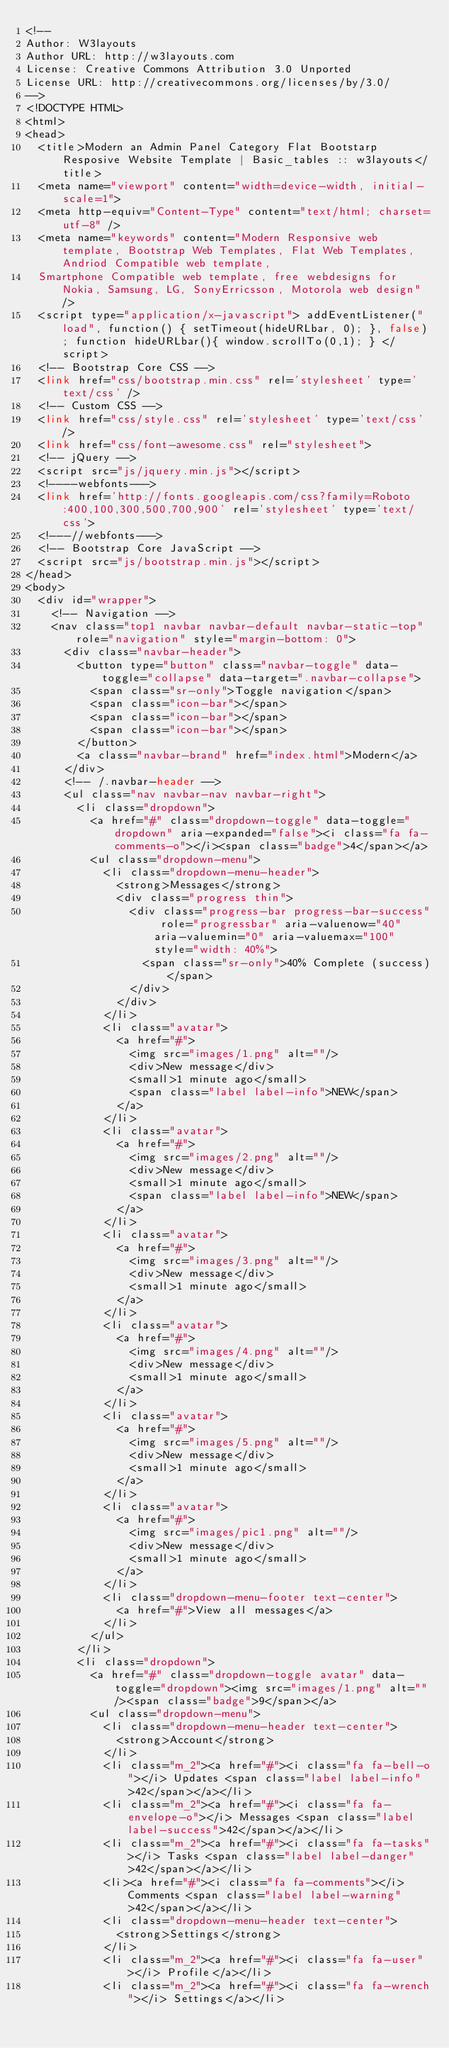<code> <loc_0><loc_0><loc_500><loc_500><_PHP_><!--
Author: W3layouts
Author URL: http://w3layouts.com
License: Creative Commons Attribution 3.0 Unported
License URL: http://creativecommons.org/licenses/by/3.0/
-->
<!DOCTYPE HTML>
<html>
<head>
	<title>Modern an Admin Panel Category Flat Bootstarp Resposive Website Template | Basic_tables :: w3layouts</title>
	<meta name="viewport" content="width=device-width, initial-scale=1">
	<meta http-equiv="Content-Type" content="text/html; charset=utf-8" />
	<meta name="keywords" content="Modern Responsive web template, Bootstrap Web Templates, Flat Web Templates, Andriod Compatible web template,
	Smartphone Compatible web template, free webdesigns for Nokia, Samsung, LG, SonyErricsson, Motorola web design" />
	<script type="application/x-javascript"> addEventListener("load", function() { setTimeout(hideURLbar, 0); }, false); function hideURLbar(){ window.scrollTo(0,1); } </script>
	<!-- Bootstrap Core CSS -->
	<link href="css/bootstrap.min.css" rel='stylesheet' type='text/css' />
	<!-- Custom CSS -->
	<link href="css/style.css" rel='stylesheet' type='text/css' />
	<link href="css/font-awesome.css" rel="stylesheet">
	<!-- jQuery -->
	<script src="js/jquery.min.js"></script>
	<!----webfonts--->
	<link href='http://fonts.googleapis.com/css?family=Roboto:400,100,300,500,700,900' rel='stylesheet' type='text/css'>
	<!---//webfonts--->
	<!-- Bootstrap Core JavaScript -->
	<script src="js/bootstrap.min.js"></script>
</head>
<body>
	<div id="wrapper">
		<!-- Navigation -->
		<nav class="top1 navbar navbar-default navbar-static-top" role="navigation" style="margin-bottom: 0">
			<div class="navbar-header">
				<button type="button" class="navbar-toggle" data-toggle="collapse" data-target=".navbar-collapse">
					<span class="sr-only">Toggle navigation</span>
					<span class="icon-bar"></span>
					<span class="icon-bar"></span>
					<span class="icon-bar"></span>
				</button>
				<a class="navbar-brand" href="index.html">Modern</a>
			</div>
			<!-- /.navbar-header -->
			<ul class="nav navbar-nav navbar-right">
				<li class="dropdown">
					<a href="#" class="dropdown-toggle" data-toggle="dropdown" aria-expanded="false"><i class="fa fa-comments-o"></i><span class="badge">4</span></a>
					<ul class="dropdown-menu">
						<li class="dropdown-menu-header">
							<strong>Messages</strong>
							<div class="progress thin">
								<div class="progress-bar progress-bar-success" role="progressbar" aria-valuenow="40" aria-valuemin="0" aria-valuemax="100" style="width: 40%">
									<span class="sr-only">40% Complete (success)</span>
								</div>
							</div>
						</li>
						<li class="avatar">
							<a href="#">
								<img src="images/1.png" alt=""/>
								<div>New message</div>
								<small>1 minute ago</small>
								<span class="label label-info">NEW</span>
							</a>
						</li>
						<li class="avatar">
							<a href="#">
								<img src="images/2.png" alt=""/>
								<div>New message</div>
								<small>1 minute ago</small>
								<span class="label label-info">NEW</span>
							</a>
						</li>
						<li class="avatar">
							<a href="#">
								<img src="images/3.png" alt=""/>
								<div>New message</div>
								<small>1 minute ago</small>
							</a>
						</li>
						<li class="avatar">
							<a href="#">
								<img src="images/4.png" alt=""/>
								<div>New message</div>
								<small>1 minute ago</small>
							</a>
						</li>
						<li class="avatar">
							<a href="#">
								<img src="images/5.png" alt=""/>
								<div>New message</div>
								<small>1 minute ago</small>
							</a>
						</li>
						<li class="avatar">
							<a href="#">
								<img src="images/pic1.png" alt=""/>
								<div>New message</div>
								<small>1 minute ago</small>
							</a>
						</li>
						<li class="dropdown-menu-footer text-center">
							<a href="#">View all messages</a>
						</li>
					</ul>
				</li>
				<li class="dropdown">
					<a href="#" class="dropdown-toggle avatar" data-toggle="dropdown"><img src="images/1.png" alt=""/><span class="badge">9</span></a>
					<ul class="dropdown-menu">
						<li class="dropdown-menu-header text-center">
							<strong>Account</strong>
						</li>
						<li class="m_2"><a href="#"><i class="fa fa-bell-o"></i> Updates <span class="label label-info">42</span></a></li>
						<li class="m_2"><a href="#"><i class="fa fa-envelope-o"></i> Messages <span class="label label-success">42</span></a></li>
						<li class="m_2"><a href="#"><i class="fa fa-tasks"></i> Tasks <span class="label label-danger">42</span></a></li>
						<li><a href="#"><i class="fa fa-comments"></i> Comments <span class="label label-warning">42</span></a></li>
						<li class="dropdown-menu-header text-center">
							<strong>Settings</strong>
						</li>
						<li class="m_2"><a href="#"><i class="fa fa-user"></i> Profile</a></li>
						<li class="m_2"><a href="#"><i class="fa fa-wrench"></i> Settings</a></li></code> 